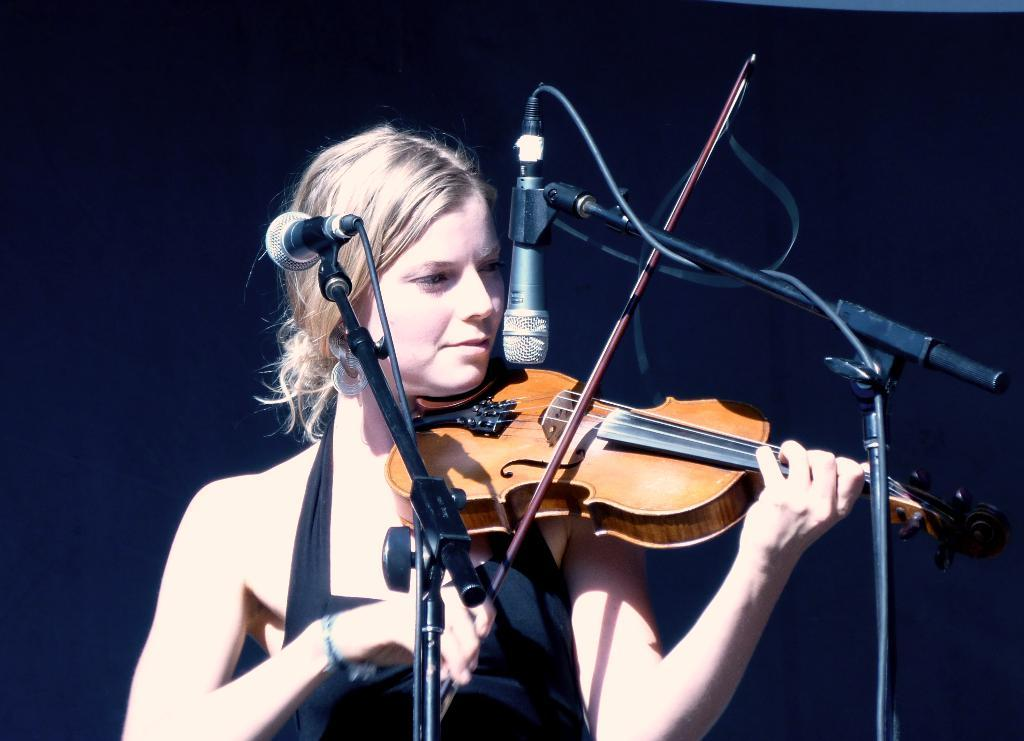Who is the main subject in the image? There is a woman in the image. What is the woman doing in the image? The woman is playing a violin. What objects are present in front of the woman? There are microphones in front of the woman. What type of bubble can be seen floating near the woman in the image? There is no bubble present in the image. 